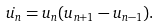Convert formula to latex. <formula><loc_0><loc_0><loc_500><loc_500>\dot { u _ { n } } = u _ { n } ( u _ { n + 1 } - u _ { n - 1 } ) .</formula> 